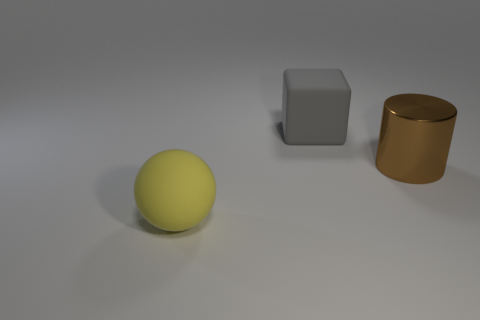Add 1 big brown objects. How many objects exist? 4 Subtract all cylinders. How many objects are left? 2 Add 1 large gray blocks. How many large gray blocks are left? 2 Add 2 big shiny things. How many big shiny things exist? 3 Subtract 0 red spheres. How many objects are left? 3 Subtract all brown metal things. Subtract all big metallic objects. How many objects are left? 1 